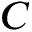Convert formula to latex. <formula><loc_0><loc_0><loc_500><loc_500>C</formula> 